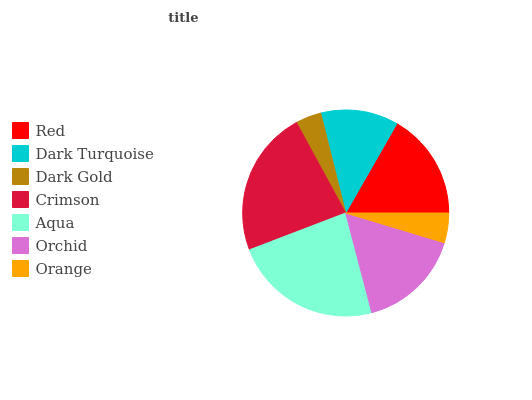Is Dark Gold the minimum?
Answer yes or no. Yes. Is Aqua the maximum?
Answer yes or no. Yes. Is Dark Turquoise the minimum?
Answer yes or no. No. Is Dark Turquoise the maximum?
Answer yes or no. No. Is Red greater than Dark Turquoise?
Answer yes or no. Yes. Is Dark Turquoise less than Red?
Answer yes or no. Yes. Is Dark Turquoise greater than Red?
Answer yes or no. No. Is Red less than Dark Turquoise?
Answer yes or no. No. Is Orchid the high median?
Answer yes or no. Yes. Is Orchid the low median?
Answer yes or no. Yes. Is Crimson the high median?
Answer yes or no. No. Is Orange the low median?
Answer yes or no. No. 